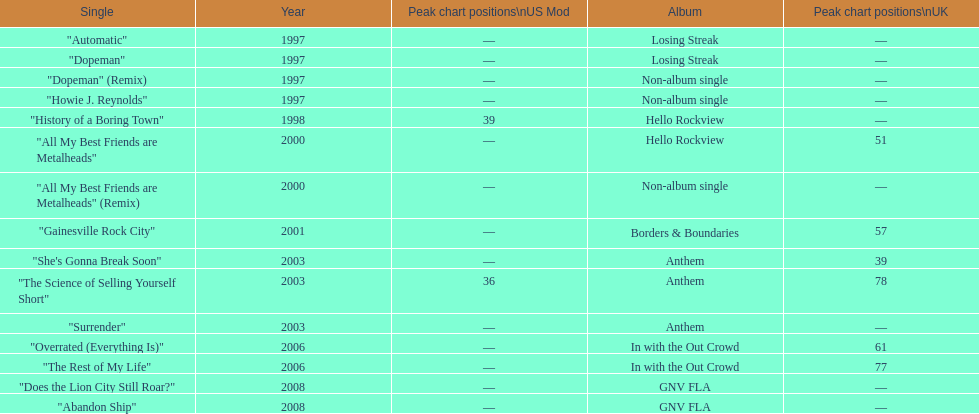What was the first single to earn a chart position? "History of a Boring Town". 